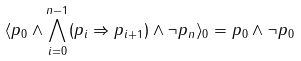Convert formula to latex. <formula><loc_0><loc_0><loc_500><loc_500>\langle p _ { 0 } \land \bigwedge _ { i = 0 } ^ { n - 1 } ( p _ { i } \Rightarrow p _ { i + 1 } ) \land \neg p _ { n } \rangle _ { 0 } & = p _ { 0 } \land \neg p _ { 0 } \\</formula> 